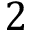<formula> <loc_0><loc_0><loc_500><loc_500>2</formula> 